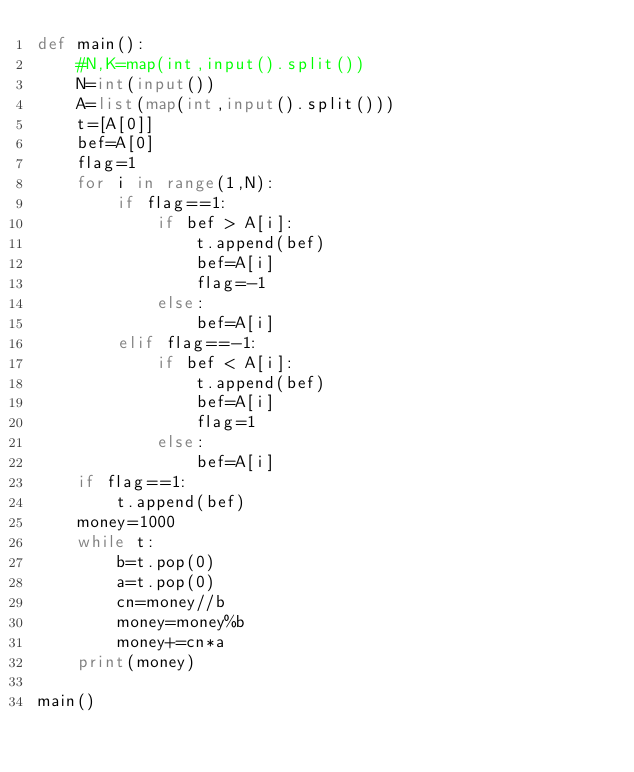<code> <loc_0><loc_0><loc_500><loc_500><_Python_>def main():
    #N,K=map(int,input().split())
    N=int(input())
    A=list(map(int,input().split()))
    t=[A[0]]
    bef=A[0]
    flag=1
    for i in range(1,N):
        if flag==1:
            if bef > A[i]:
                t.append(bef)
                bef=A[i]
                flag=-1
            else:
                bef=A[i]
        elif flag==-1:
            if bef < A[i]:
                t.append(bef)
                bef=A[i]
                flag=1
            else:
                bef=A[i]
    if flag==1:
        t.append(bef)
    money=1000
    while t:
        b=t.pop(0)
        a=t.pop(0)
        cn=money//b
        money=money%b
        money+=cn*a
    print(money)

main()</code> 